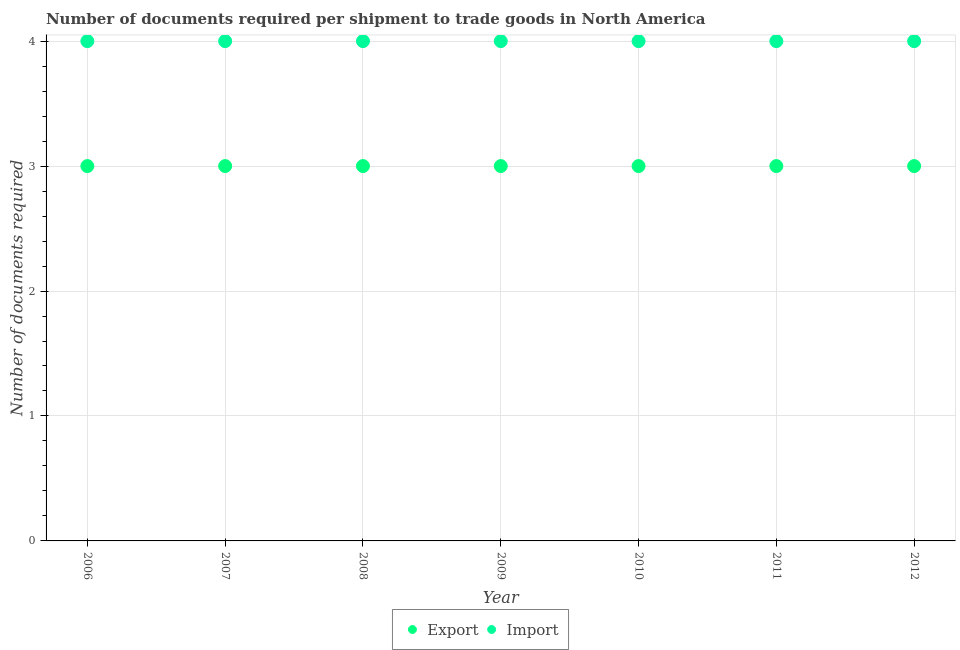How many different coloured dotlines are there?
Provide a succinct answer. 2. What is the number of documents required to export goods in 2008?
Make the answer very short. 3. Across all years, what is the maximum number of documents required to export goods?
Your answer should be compact. 3. Across all years, what is the minimum number of documents required to export goods?
Your response must be concise. 3. In which year was the number of documents required to export goods maximum?
Provide a short and direct response. 2006. What is the total number of documents required to export goods in the graph?
Give a very brief answer. 21. What is the difference between the number of documents required to import goods in 2007 and the number of documents required to export goods in 2008?
Your answer should be compact. 1. What is the average number of documents required to import goods per year?
Your answer should be compact. 4. In the year 2006, what is the difference between the number of documents required to export goods and number of documents required to import goods?
Give a very brief answer. -1. What is the difference between the highest and the lowest number of documents required to import goods?
Your answer should be very brief. 0. Does the number of documents required to export goods monotonically increase over the years?
Your response must be concise. No. Is the number of documents required to export goods strictly less than the number of documents required to import goods over the years?
Provide a succinct answer. Yes. What is the difference between two consecutive major ticks on the Y-axis?
Offer a very short reply. 1. Where does the legend appear in the graph?
Provide a succinct answer. Bottom center. How many legend labels are there?
Offer a terse response. 2. What is the title of the graph?
Make the answer very short. Number of documents required per shipment to trade goods in North America. What is the label or title of the X-axis?
Provide a short and direct response. Year. What is the label or title of the Y-axis?
Give a very brief answer. Number of documents required. What is the Number of documents required of Export in 2006?
Offer a very short reply. 3. What is the Number of documents required of Export in 2008?
Give a very brief answer. 3. What is the Number of documents required of Import in 2008?
Provide a succinct answer. 4. What is the Number of documents required in Export in 2009?
Your answer should be compact. 3. What is the Number of documents required in Import in 2009?
Your response must be concise. 4. What is the Number of documents required of Import in 2010?
Offer a terse response. 4. What is the Number of documents required in Import in 2011?
Your response must be concise. 4. What is the Number of documents required of Export in 2012?
Ensure brevity in your answer.  3. Across all years, what is the maximum Number of documents required of Export?
Provide a short and direct response. 3. What is the total Number of documents required in Export in the graph?
Offer a very short reply. 21. What is the total Number of documents required in Import in the graph?
Offer a very short reply. 28. What is the difference between the Number of documents required of Export in 2006 and that in 2007?
Keep it short and to the point. 0. What is the difference between the Number of documents required of Export in 2006 and that in 2008?
Your answer should be very brief. 0. What is the difference between the Number of documents required in Export in 2006 and that in 2009?
Provide a short and direct response. 0. What is the difference between the Number of documents required of Export in 2006 and that in 2010?
Offer a terse response. 0. What is the difference between the Number of documents required in Import in 2006 and that in 2010?
Your answer should be very brief. 0. What is the difference between the Number of documents required of Export in 2006 and that in 2011?
Your answer should be compact. 0. What is the difference between the Number of documents required in Import in 2006 and that in 2011?
Offer a very short reply. 0. What is the difference between the Number of documents required of Export in 2006 and that in 2012?
Give a very brief answer. 0. What is the difference between the Number of documents required in Import in 2006 and that in 2012?
Ensure brevity in your answer.  0. What is the difference between the Number of documents required in Export in 2007 and that in 2008?
Your answer should be very brief. 0. What is the difference between the Number of documents required of Import in 2007 and that in 2008?
Ensure brevity in your answer.  0. What is the difference between the Number of documents required in Import in 2007 and that in 2010?
Ensure brevity in your answer.  0. What is the difference between the Number of documents required in Export in 2007 and that in 2011?
Provide a succinct answer. 0. What is the difference between the Number of documents required in Import in 2007 and that in 2011?
Ensure brevity in your answer.  0. What is the difference between the Number of documents required of Import in 2007 and that in 2012?
Your answer should be very brief. 0. What is the difference between the Number of documents required in Export in 2008 and that in 2009?
Your response must be concise. 0. What is the difference between the Number of documents required of Import in 2008 and that in 2009?
Your answer should be very brief. 0. What is the difference between the Number of documents required in Export in 2008 and that in 2010?
Your answer should be very brief. 0. What is the difference between the Number of documents required in Export in 2008 and that in 2012?
Give a very brief answer. 0. What is the difference between the Number of documents required of Import in 2008 and that in 2012?
Ensure brevity in your answer.  0. What is the difference between the Number of documents required of Export in 2009 and that in 2011?
Offer a terse response. 0. What is the difference between the Number of documents required in Import in 2009 and that in 2011?
Provide a succinct answer. 0. What is the difference between the Number of documents required in Export in 2010 and that in 2012?
Provide a succinct answer. 0. What is the difference between the Number of documents required of Import in 2010 and that in 2012?
Your answer should be very brief. 0. What is the difference between the Number of documents required in Export in 2006 and the Number of documents required in Import in 2009?
Give a very brief answer. -1. What is the difference between the Number of documents required in Export in 2006 and the Number of documents required in Import in 2010?
Make the answer very short. -1. What is the difference between the Number of documents required of Export in 2006 and the Number of documents required of Import in 2011?
Give a very brief answer. -1. What is the difference between the Number of documents required of Export in 2007 and the Number of documents required of Import in 2009?
Ensure brevity in your answer.  -1. What is the difference between the Number of documents required of Export in 2007 and the Number of documents required of Import in 2010?
Give a very brief answer. -1. What is the difference between the Number of documents required of Export in 2007 and the Number of documents required of Import in 2012?
Offer a very short reply. -1. What is the difference between the Number of documents required of Export in 2008 and the Number of documents required of Import in 2011?
Provide a succinct answer. -1. What is the difference between the Number of documents required in Export in 2009 and the Number of documents required in Import in 2010?
Your answer should be compact. -1. What is the difference between the Number of documents required in Export in 2009 and the Number of documents required in Import in 2012?
Give a very brief answer. -1. What is the difference between the Number of documents required in Export in 2010 and the Number of documents required in Import in 2011?
Give a very brief answer. -1. What is the difference between the Number of documents required of Export in 2011 and the Number of documents required of Import in 2012?
Your answer should be compact. -1. In the year 2006, what is the difference between the Number of documents required in Export and Number of documents required in Import?
Your response must be concise. -1. In the year 2007, what is the difference between the Number of documents required in Export and Number of documents required in Import?
Offer a very short reply. -1. In the year 2008, what is the difference between the Number of documents required in Export and Number of documents required in Import?
Provide a succinct answer. -1. In the year 2009, what is the difference between the Number of documents required of Export and Number of documents required of Import?
Give a very brief answer. -1. In the year 2011, what is the difference between the Number of documents required in Export and Number of documents required in Import?
Keep it short and to the point. -1. What is the ratio of the Number of documents required of Export in 2006 to that in 2007?
Provide a succinct answer. 1. What is the ratio of the Number of documents required of Import in 2006 to that in 2008?
Make the answer very short. 1. What is the ratio of the Number of documents required in Import in 2006 to that in 2009?
Your response must be concise. 1. What is the ratio of the Number of documents required in Export in 2006 to that in 2011?
Offer a terse response. 1. What is the ratio of the Number of documents required of Import in 2006 to that in 2011?
Keep it short and to the point. 1. What is the ratio of the Number of documents required in Export in 2006 to that in 2012?
Give a very brief answer. 1. What is the ratio of the Number of documents required in Import in 2006 to that in 2012?
Give a very brief answer. 1. What is the ratio of the Number of documents required of Import in 2007 to that in 2008?
Make the answer very short. 1. What is the ratio of the Number of documents required of Import in 2007 to that in 2010?
Ensure brevity in your answer.  1. What is the ratio of the Number of documents required in Export in 2007 to that in 2011?
Offer a terse response. 1. What is the ratio of the Number of documents required of Import in 2007 to that in 2011?
Keep it short and to the point. 1. What is the ratio of the Number of documents required in Export in 2008 to that in 2009?
Keep it short and to the point. 1. What is the ratio of the Number of documents required in Import in 2008 to that in 2009?
Your response must be concise. 1. What is the ratio of the Number of documents required of Export in 2008 to that in 2010?
Keep it short and to the point. 1. What is the ratio of the Number of documents required of Import in 2008 to that in 2011?
Offer a very short reply. 1. What is the ratio of the Number of documents required in Import in 2009 to that in 2010?
Provide a short and direct response. 1. What is the ratio of the Number of documents required in Export in 2009 to that in 2011?
Provide a short and direct response. 1. What is the ratio of the Number of documents required of Import in 2009 to that in 2011?
Provide a short and direct response. 1. What is the ratio of the Number of documents required in Import in 2009 to that in 2012?
Ensure brevity in your answer.  1. What is the ratio of the Number of documents required of Export in 2011 to that in 2012?
Provide a short and direct response. 1. What is the ratio of the Number of documents required of Import in 2011 to that in 2012?
Ensure brevity in your answer.  1. What is the difference between the highest and the lowest Number of documents required of Import?
Offer a very short reply. 0. 